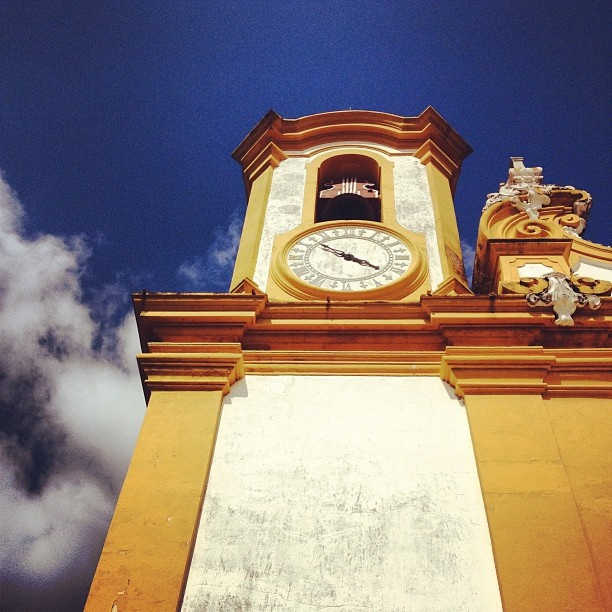Describe the objects in this image and their specific colors. I can see a clock in navy, beige, darkgray, and tan tones in this image. 